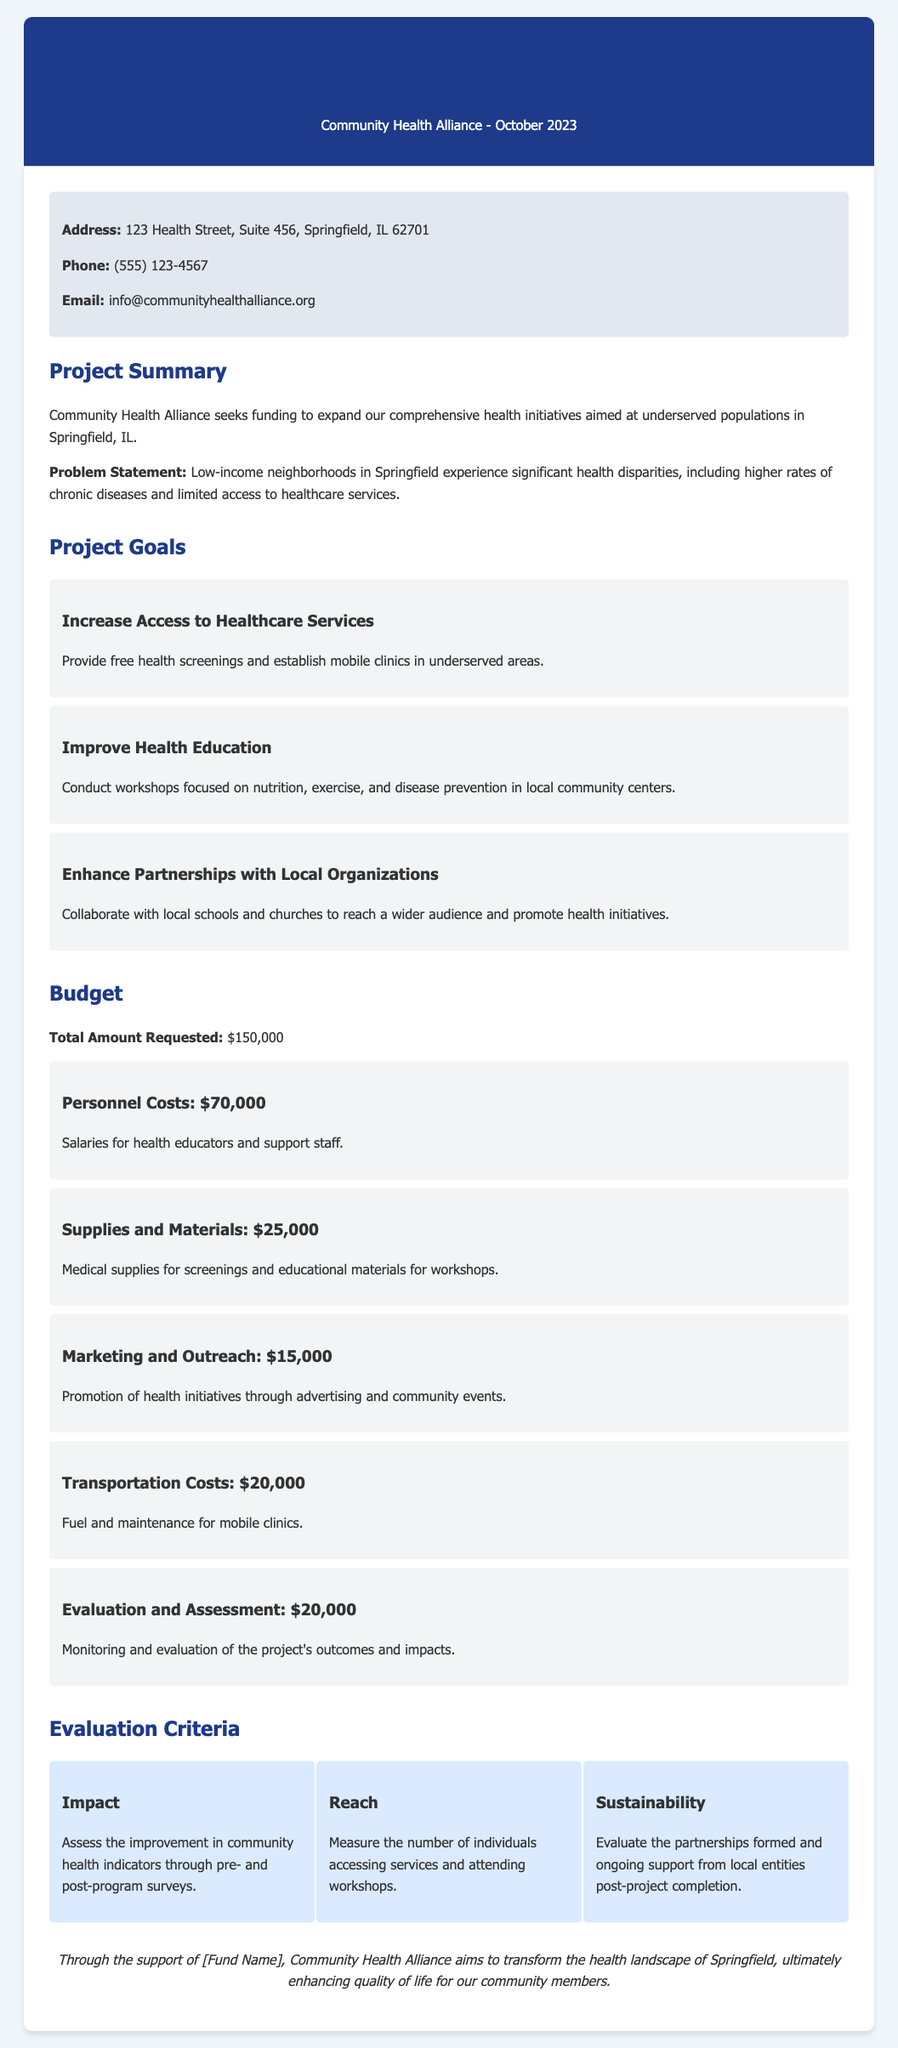What is the total amount requested? The total amount requested is noted in the budget section as $150,000.
Answer: $150,000 What are the first two project goals? The first two project goals are listed as increasing access to healthcare services and improving health education.
Answer: Increase Access to Healthcare Services, Improve Health Education How much is allocated for marketing and outreach? The budget section specifically states that $15,000 is allocated for marketing and outreach.
Answer: $15,000 What is included in the evaluation criteria? The evaluation criteria includes impact, reach, and sustainability as key measures for the project.
Answer: Impact, Reach, Sustainability What platforms are used for outreach in the project? The project aims to enhance partnerships with local organizations such as schools and churches for outreach.
Answer: Local schools and churches What is the purpose of the evaluation and assessment budget item? The purpose of the evaluation and assessment budget item is to monitor and evaluate the project's outcomes and impacts.
Answer: Monitoring and evaluation of the project's outcomes and impacts When was the proposal created? The proposal was created in October 2023, as noted in the header.
Answer: October 2023 What type of organization is Community Health Alliance? Based on the document, Community Health Alliance is categorized as a non-profit organization focused on health initiatives.
Answer: Non-profit organization 